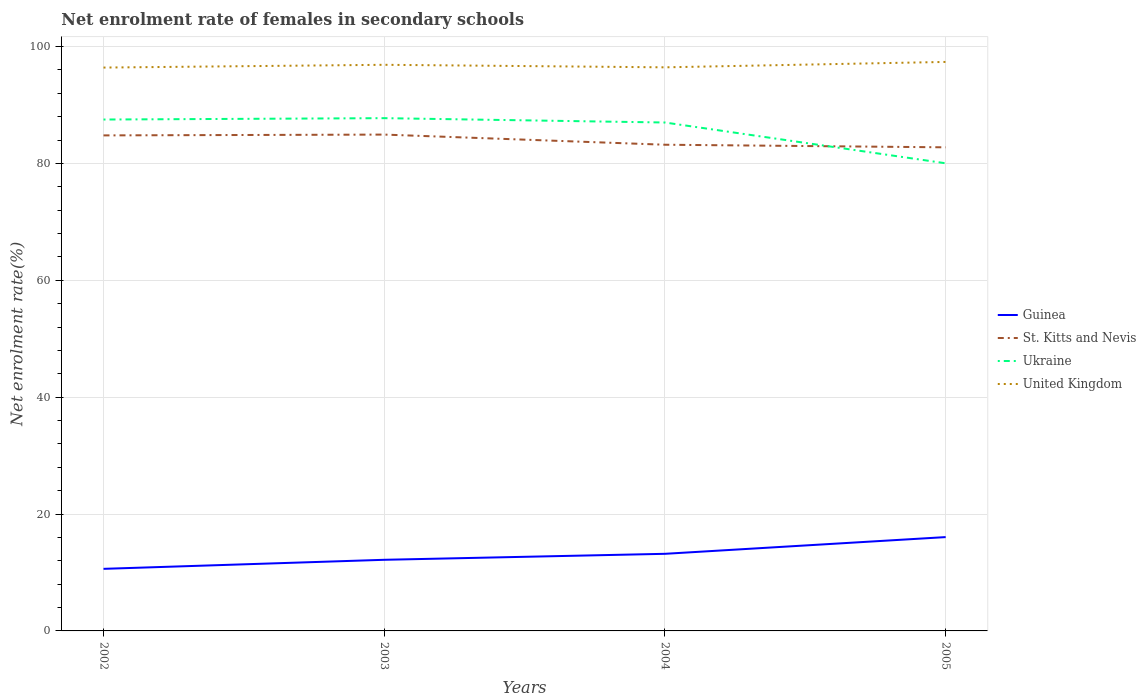Is the number of lines equal to the number of legend labels?
Offer a terse response. Yes. Across all years, what is the maximum net enrolment rate of females in secondary schools in Guinea?
Make the answer very short. 10.62. What is the total net enrolment rate of females in secondary schools in Ukraine in the graph?
Your response must be concise. 0.74. What is the difference between the highest and the second highest net enrolment rate of females in secondary schools in Guinea?
Offer a terse response. 5.43. What is the difference between the highest and the lowest net enrolment rate of females in secondary schools in St. Kitts and Nevis?
Your answer should be compact. 2. What is the difference between two consecutive major ticks on the Y-axis?
Provide a short and direct response. 20. Are the values on the major ticks of Y-axis written in scientific E-notation?
Your answer should be very brief. No. Does the graph contain grids?
Offer a terse response. Yes. Where does the legend appear in the graph?
Ensure brevity in your answer.  Center right. How many legend labels are there?
Offer a terse response. 4. What is the title of the graph?
Your answer should be very brief. Net enrolment rate of females in secondary schools. What is the label or title of the Y-axis?
Provide a succinct answer. Net enrolment rate(%). What is the Net enrolment rate(%) in Guinea in 2002?
Provide a succinct answer. 10.62. What is the Net enrolment rate(%) of St. Kitts and Nevis in 2002?
Ensure brevity in your answer.  84.8. What is the Net enrolment rate(%) in Ukraine in 2002?
Keep it short and to the point. 87.51. What is the Net enrolment rate(%) of United Kingdom in 2002?
Keep it short and to the point. 96.4. What is the Net enrolment rate(%) in Guinea in 2003?
Ensure brevity in your answer.  12.17. What is the Net enrolment rate(%) in St. Kitts and Nevis in 2003?
Give a very brief answer. 84.94. What is the Net enrolment rate(%) in Ukraine in 2003?
Offer a terse response. 87.75. What is the Net enrolment rate(%) in United Kingdom in 2003?
Offer a terse response. 96.88. What is the Net enrolment rate(%) in Guinea in 2004?
Provide a succinct answer. 13.2. What is the Net enrolment rate(%) of St. Kitts and Nevis in 2004?
Your answer should be very brief. 83.2. What is the Net enrolment rate(%) of Ukraine in 2004?
Your answer should be very brief. 87. What is the Net enrolment rate(%) of United Kingdom in 2004?
Keep it short and to the point. 96.44. What is the Net enrolment rate(%) of Guinea in 2005?
Make the answer very short. 16.06. What is the Net enrolment rate(%) in St. Kitts and Nevis in 2005?
Offer a very short reply. 82.76. What is the Net enrolment rate(%) of Ukraine in 2005?
Give a very brief answer. 80.02. What is the Net enrolment rate(%) of United Kingdom in 2005?
Your response must be concise. 97.37. Across all years, what is the maximum Net enrolment rate(%) of Guinea?
Your response must be concise. 16.06. Across all years, what is the maximum Net enrolment rate(%) of St. Kitts and Nevis?
Provide a short and direct response. 84.94. Across all years, what is the maximum Net enrolment rate(%) in Ukraine?
Give a very brief answer. 87.75. Across all years, what is the maximum Net enrolment rate(%) of United Kingdom?
Offer a very short reply. 97.37. Across all years, what is the minimum Net enrolment rate(%) in Guinea?
Keep it short and to the point. 10.62. Across all years, what is the minimum Net enrolment rate(%) in St. Kitts and Nevis?
Make the answer very short. 82.76. Across all years, what is the minimum Net enrolment rate(%) in Ukraine?
Ensure brevity in your answer.  80.02. Across all years, what is the minimum Net enrolment rate(%) of United Kingdom?
Make the answer very short. 96.4. What is the total Net enrolment rate(%) in Guinea in the graph?
Your answer should be compact. 52.05. What is the total Net enrolment rate(%) in St. Kitts and Nevis in the graph?
Make the answer very short. 335.69. What is the total Net enrolment rate(%) in Ukraine in the graph?
Provide a succinct answer. 342.28. What is the total Net enrolment rate(%) in United Kingdom in the graph?
Your answer should be very brief. 387.1. What is the difference between the Net enrolment rate(%) of Guinea in 2002 and that in 2003?
Your response must be concise. -1.55. What is the difference between the Net enrolment rate(%) of St. Kitts and Nevis in 2002 and that in 2003?
Offer a very short reply. -0.14. What is the difference between the Net enrolment rate(%) of Ukraine in 2002 and that in 2003?
Ensure brevity in your answer.  -0.24. What is the difference between the Net enrolment rate(%) in United Kingdom in 2002 and that in 2003?
Ensure brevity in your answer.  -0.47. What is the difference between the Net enrolment rate(%) in Guinea in 2002 and that in 2004?
Provide a short and direct response. -2.57. What is the difference between the Net enrolment rate(%) in St. Kitts and Nevis in 2002 and that in 2004?
Your response must be concise. 1.6. What is the difference between the Net enrolment rate(%) in Ukraine in 2002 and that in 2004?
Make the answer very short. 0.51. What is the difference between the Net enrolment rate(%) of United Kingdom in 2002 and that in 2004?
Your answer should be very brief. -0.04. What is the difference between the Net enrolment rate(%) in Guinea in 2002 and that in 2005?
Provide a succinct answer. -5.43. What is the difference between the Net enrolment rate(%) in St. Kitts and Nevis in 2002 and that in 2005?
Provide a short and direct response. 2.04. What is the difference between the Net enrolment rate(%) in Ukraine in 2002 and that in 2005?
Provide a short and direct response. 7.49. What is the difference between the Net enrolment rate(%) in United Kingdom in 2002 and that in 2005?
Provide a succinct answer. -0.97. What is the difference between the Net enrolment rate(%) of Guinea in 2003 and that in 2004?
Give a very brief answer. -1.03. What is the difference between the Net enrolment rate(%) of St. Kitts and Nevis in 2003 and that in 2004?
Give a very brief answer. 1.74. What is the difference between the Net enrolment rate(%) of Ukraine in 2003 and that in 2004?
Offer a terse response. 0.74. What is the difference between the Net enrolment rate(%) in United Kingdom in 2003 and that in 2004?
Make the answer very short. 0.43. What is the difference between the Net enrolment rate(%) of Guinea in 2003 and that in 2005?
Your answer should be very brief. -3.89. What is the difference between the Net enrolment rate(%) of St. Kitts and Nevis in 2003 and that in 2005?
Offer a terse response. 2.18. What is the difference between the Net enrolment rate(%) of Ukraine in 2003 and that in 2005?
Give a very brief answer. 7.72. What is the difference between the Net enrolment rate(%) of United Kingdom in 2003 and that in 2005?
Your response must be concise. -0.49. What is the difference between the Net enrolment rate(%) in Guinea in 2004 and that in 2005?
Your answer should be very brief. -2.86. What is the difference between the Net enrolment rate(%) in St. Kitts and Nevis in 2004 and that in 2005?
Your answer should be compact. 0.44. What is the difference between the Net enrolment rate(%) in Ukraine in 2004 and that in 2005?
Give a very brief answer. 6.98. What is the difference between the Net enrolment rate(%) of United Kingdom in 2004 and that in 2005?
Your answer should be compact. -0.93. What is the difference between the Net enrolment rate(%) of Guinea in 2002 and the Net enrolment rate(%) of St. Kitts and Nevis in 2003?
Offer a terse response. -74.31. What is the difference between the Net enrolment rate(%) of Guinea in 2002 and the Net enrolment rate(%) of Ukraine in 2003?
Make the answer very short. -77.12. What is the difference between the Net enrolment rate(%) of Guinea in 2002 and the Net enrolment rate(%) of United Kingdom in 2003?
Give a very brief answer. -86.26. What is the difference between the Net enrolment rate(%) in St. Kitts and Nevis in 2002 and the Net enrolment rate(%) in Ukraine in 2003?
Your answer should be compact. -2.95. What is the difference between the Net enrolment rate(%) in St. Kitts and Nevis in 2002 and the Net enrolment rate(%) in United Kingdom in 2003?
Your response must be concise. -12.08. What is the difference between the Net enrolment rate(%) of Ukraine in 2002 and the Net enrolment rate(%) of United Kingdom in 2003?
Ensure brevity in your answer.  -9.37. What is the difference between the Net enrolment rate(%) of Guinea in 2002 and the Net enrolment rate(%) of St. Kitts and Nevis in 2004?
Make the answer very short. -72.58. What is the difference between the Net enrolment rate(%) of Guinea in 2002 and the Net enrolment rate(%) of Ukraine in 2004?
Offer a terse response. -76.38. What is the difference between the Net enrolment rate(%) of Guinea in 2002 and the Net enrolment rate(%) of United Kingdom in 2004?
Make the answer very short. -85.82. What is the difference between the Net enrolment rate(%) of St. Kitts and Nevis in 2002 and the Net enrolment rate(%) of Ukraine in 2004?
Your answer should be compact. -2.21. What is the difference between the Net enrolment rate(%) of St. Kitts and Nevis in 2002 and the Net enrolment rate(%) of United Kingdom in 2004?
Provide a succinct answer. -11.65. What is the difference between the Net enrolment rate(%) of Ukraine in 2002 and the Net enrolment rate(%) of United Kingdom in 2004?
Your answer should be very brief. -8.93. What is the difference between the Net enrolment rate(%) in Guinea in 2002 and the Net enrolment rate(%) in St. Kitts and Nevis in 2005?
Keep it short and to the point. -72.13. What is the difference between the Net enrolment rate(%) of Guinea in 2002 and the Net enrolment rate(%) of Ukraine in 2005?
Keep it short and to the point. -69.4. What is the difference between the Net enrolment rate(%) in Guinea in 2002 and the Net enrolment rate(%) in United Kingdom in 2005?
Your response must be concise. -86.75. What is the difference between the Net enrolment rate(%) in St. Kitts and Nevis in 2002 and the Net enrolment rate(%) in Ukraine in 2005?
Offer a terse response. 4.77. What is the difference between the Net enrolment rate(%) of St. Kitts and Nevis in 2002 and the Net enrolment rate(%) of United Kingdom in 2005?
Make the answer very short. -12.57. What is the difference between the Net enrolment rate(%) of Ukraine in 2002 and the Net enrolment rate(%) of United Kingdom in 2005?
Provide a succinct answer. -9.86. What is the difference between the Net enrolment rate(%) of Guinea in 2003 and the Net enrolment rate(%) of St. Kitts and Nevis in 2004?
Give a very brief answer. -71.03. What is the difference between the Net enrolment rate(%) in Guinea in 2003 and the Net enrolment rate(%) in Ukraine in 2004?
Provide a short and direct response. -74.83. What is the difference between the Net enrolment rate(%) of Guinea in 2003 and the Net enrolment rate(%) of United Kingdom in 2004?
Offer a terse response. -84.27. What is the difference between the Net enrolment rate(%) in St. Kitts and Nevis in 2003 and the Net enrolment rate(%) in Ukraine in 2004?
Provide a short and direct response. -2.07. What is the difference between the Net enrolment rate(%) in St. Kitts and Nevis in 2003 and the Net enrolment rate(%) in United Kingdom in 2004?
Ensure brevity in your answer.  -11.51. What is the difference between the Net enrolment rate(%) of Ukraine in 2003 and the Net enrolment rate(%) of United Kingdom in 2004?
Your answer should be compact. -8.7. What is the difference between the Net enrolment rate(%) in Guinea in 2003 and the Net enrolment rate(%) in St. Kitts and Nevis in 2005?
Give a very brief answer. -70.58. What is the difference between the Net enrolment rate(%) in Guinea in 2003 and the Net enrolment rate(%) in Ukraine in 2005?
Make the answer very short. -67.85. What is the difference between the Net enrolment rate(%) in Guinea in 2003 and the Net enrolment rate(%) in United Kingdom in 2005?
Ensure brevity in your answer.  -85.2. What is the difference between the Net enrolment rate(%) in St. Kitts and Nevis in 2003 and the Net enrolment rate(%) in Ukraine in 2005?
Your answer should be compact. 4.91. What is the difference between the Net enrolment rate(%) in St. Kitts and Nevis in 2003 and the Net enrolment rate(%) in United Kingdom in 2005?
Keep it short and to the point. -12.43. What is the difference between the Net enrolment rate(%) in Ukraine in 2003 and the Net enrolment rate(%) in United Kingdom in 2005?
Offer a very short reply. -9.62. What is the difference between the Net enrolment rate(%) of Guinea in 2004 and the Net enrolment rate(%) of St. Kitts and Nevis in 2005?
Provide a short and direct response. -69.56. What is the difference between the Net enrolment rate(%) of Guinea in 2004 and the Net enrolment rate(%) of Ukraine in 2005?
Offer a terse response. -66.83. What is the difference between the Net enrolment rate(%) of Guinea in 2004 and the Net enrolment rate(%) of United Kingdom in 2005?
Make the answer very short. -84.17. What is the difference between the Net enrolment rate(%) of St. Kitts and Nevis in 2004 and the Net enrolment rate(%) of Ukraine in 2005?
Keep it short and to the point. 3.17. What is the difference between the Net enrolment rate(%) in St. Kitts and Nevis in 2004 and the Net enrolment rate(%) in United Kingdom in 2005?
Provide a short and direct response. -14.17. What is the difference between the Net enrolment rate(%) of Ukraine in 2004 and the Net enrolment rate(%) of United Kingdom in 2005?
Offer a terse response. -10.37. What is the average Net enrolment rate(%) in Guinea per year?
Your response must be concise. 13.01. What is the average Net enrolment rate(%) of St. Kitts and Nevis per year?
Give a very brief answer. 83.92. What is the average Net enrolment rate(%) in Ukraine per year?
Give a very brief answer. 85.57. What is the average Net enrolment rate(%) in United Kingdom per year?
Keep it short and to the point. 96.77. In the year 2002, what is the difference between the Net enrolment rate(%) in Guinea and Net enrolment rate(%) in St. Kitts and Nevis?
Offer a terse response. -74.17. In the year 2002, what is the difference between the Net enrolment rate(%) in Guinea and Net enrolment rate(%) in Ukraine?
Provide a succinct answer. -76.89. In the year 2002, what is the difference between the Net enrolment rate(%) of Guinea and Net enrolment rate(%) of United Kingdom?
Give a very brief answer. -85.78. In the year 2002, what is the difference between the Net enrolment rate(%) of St. Kitts and Nevis and Net enrolment rate(%) of Ukraine?
Give a very brief answer. -2.71. In the year 2002, what is the difference between the Net enrolment rate(%) of St. Kitts and Nevis and Net enrolment rate(%) of United Kingdom?
Give a very brief answer. -11.61. In the year 2002, what is the difference between the Net enrolment rate(%) of Ukraine and Net enrolment rate(%) of United Kingdom?
Keep it short and to the point. -8.89. In the year 2003, what is the difference between the Net enrolment rate(%) of Guinea and Net enrolment rate(%) of St. Kitts and Nevis?
Keep it short and to the point. -72.76. In the year 2003, what is the difference between the Net enrolment rate(%) in Guinea and Net enrolment rate(%) in Ukraine?
Provide a short and direct response. -75.58. In the year 2003, what is the difference between the Net enrolment rate(%) in Guinea and Net enrolment rate(%) in United Kingdom?
Your answer should be compact. -84.71. In the year 2003, what is the difference between the Net enrolment rate(%) of St. Kitts and Nevis and Net enrolment rate(%) of Ukraine?
Your answer should be compact. -2.81. In the year 2003, what is the difference between the Net enrolment rate(%) in St. Kitts and Nevis and Net enrolment rate(%) in United Kingdom?
Provide a short and direct response. -11.94. In the year 2003, what is the difference between the Net enrolment rate(%) in Ukraine and Net enrolment rate(%) in United Kingdom?
Ensure brevity in your answer.  -9.13. In the year 2004, what is the difference between the Net enrolment rate(%) in Guinea and Net enrolment rate(%) in St. Kitts and Nevis?
Your response must be concise. -70. In the year 2004, what is the difference between the Net enrolment rate(%) in Guinea and Net enrolment rate(%) in Ukraine?
Give a very brief answer. -73.81. In the year 2004, what is the difference between the Net enrolment rate(%) in Guinea and Net enrolment rate(%) in United Kingdom?
Ensure brevity in your answer.  -83.25. In the year 2004, what is the difference between the Net enrolment rate(%) of St. Kitts and Nevis and Net enrolment rate(%) of Ukraine?
Your response must be concise. -3.8. In the year 2004, what is the difference between the Net enrolment rate(%) of St. Kitts and Nevis and Net enrolment rate(%) of United Kingdom?
Your answer should be compact. -13.24. In the year 2004, what is the difference between the Net enrolment rate(%) in Ukraine and Net enrolment rate(%) in United Kingdom?
Offer a terse response. -9.44. In the year 2005, what is the difference between the Net enrolment rate(%) in Guinea and Net enrolment rate(%) in St. Kitts and Nevis?
Make the answer very short. -66.7. In the year 2005, what is the difference between the Net enrolment rate(%) in Guinea and Net enrolment rate(%) in Ukraine?
Your answer should be very brief. -63.97. In the year 2005, what is the difference between the Net enrolment rate(%) in Guinea and Net enrolment rate(%) in United Kingdom?
Your response must be concise. -81.31. In the year 2005, what is the difference between the Net enrolment rate(%) of St. Kitts and Nevis and Net enrolment rate(%) of Ukraine?
Ensure brevity in your answer.  2.73. In the year 2005, what is the difference between the Net enrolment rate(%) of St. Kitts and Nevis and Net enrolment rate(%) of United Kingdom?
Your response must be concise. -14.61. In the year 2005, what is the difference between the Net enrolment rate(%) of Ukraine and Net enrolment rate(%) of United Kingdom?
Your answer should be compact. -17.35. What is the ratio of the Net enrolment rate(%) of Guinea in 2002 to that in 2003?
Offer a terse response. 0.87. What is the ratio of the Net enrolment rate(%) in United Kingdom in 2002 to that in 2003?
Your answer should be compact. 1. What is the ratio of the Net enrolment rate(%) in Guinea in 2002 to that in 2004?
Your answer should be compact. 0.81. What is the ratio of the Net enrolment rate(%) of St. Kitts and Nevis in 2002 to that in 2004?
Give a very brief answer. 1.02. What is the ratio of the Net enrolment rate(%) in Ukraine in 2002 to that in 2004?
Give a very brief answer. 1.01. What is the ratio of the Net enrolment rate(%) of Guinea in 2002 to that in 2005?
Your response must be concise. 0.66. What is the ratio of the Net enrolment rate(%) of St. Kitts and Nevis in 2002 to that in 2005?
Your answer should be compact. 1.02. What is the ratio of the Net enrolment rate(%) in Ukraine in 2002 to that in 2005?
Provide a succinct answer. 1.09. What is the ratio of the Net enrolment rate(%) of United Kingdom in 2002 to that in 2005?
Provide a short and direct response. 0.99. What is the ratio of the Net enrolment rate(%) of Guinea in 2003 to that in 2004?
Your answer should be very brief. 0.92. What is the ratio of the Net enrolment rate(%) in St. Kitts and Nevis in 2003 to that in 2004?
Ensure brevity in your answer.  1.02. What is the ratio of the Net enrolment rate(%) of Ukraine in 2003 to that in 2004?
Keep it short and to the point. 1.01. What is the ratio of the Net enrolment rate(%) of Guinea in 2003 to that in 2005?
Offer a terse response. 0.76. What is the ratio of the Net enrolment rate(%) of St. Kitts and Nevis in 2003 to that in 2005?
Provide a short and direct response. 1.03. What is the ratio of the Net enrolment rate(%) in Ukraine in 2003 to that in 2005?
Keep it short and to the point. 1.1. What is the ratio of the Net enrolment rate(%) of United Kingdom in 2003 to that in 2005?
Provide a succinct answer. 0.99. What is the ratio of the Net enrolment rate(%) of Guinea in 2004 to that in 2005?
Give a very brief answer. 0.82. What is the ratio of the Net enrolment rate(%) of St. Kitts and Nevis in 2004 to that in 2005?
Provide a succinct answer. 1.01. What is the ratio of the Net enrolment rate(%) of Ukraine in 2004 to that in 2005?
Make the answer very short. 1.09. What is the difference between the highest and the second highest Net enrolment rate(%) of Guinea?
Offer a very short reply. 2.86. What is the difference between the highest and the second highest Net enrolment rate(%) of St. Kitts and Nevis?
Ensure brevity in your answer.  0.14. What is the difference between the highest and the second highest Net enrolment rate(%) of Ukraine?
Provide a short and direct response. 0.24. What is the difference between the highest and the second highest Net enrolment rate(%) of United Kingdom?
Offer a terse response. 0.49. What is the difference between the highest and the lowest Net enrolment rate(%) in Guinea?
Your answer should be compact. 5.43. What is the difference between the highest and the lowest Net enrolment rate(%) in St. Kitts and Nevis?
Ensure brevity in your answer.  2.18. What is the difference between the highest and the lowest Net enrolment rate(%) of Ukraine?
Keep it short and to the point. 7.72. What is the difference between the highest and the lowest Net enrolment rate(%) of United Kingdom?
Give a very brief answer. 0.97. 